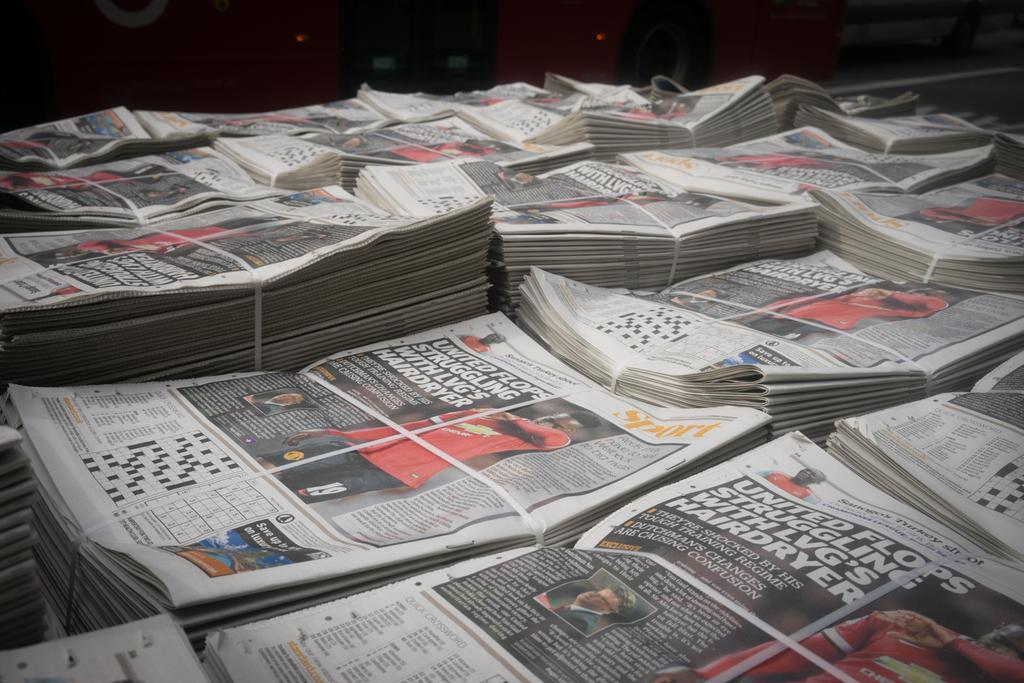<image>
Describe the image concisely. A lot of newspapers with an article about United flops. 